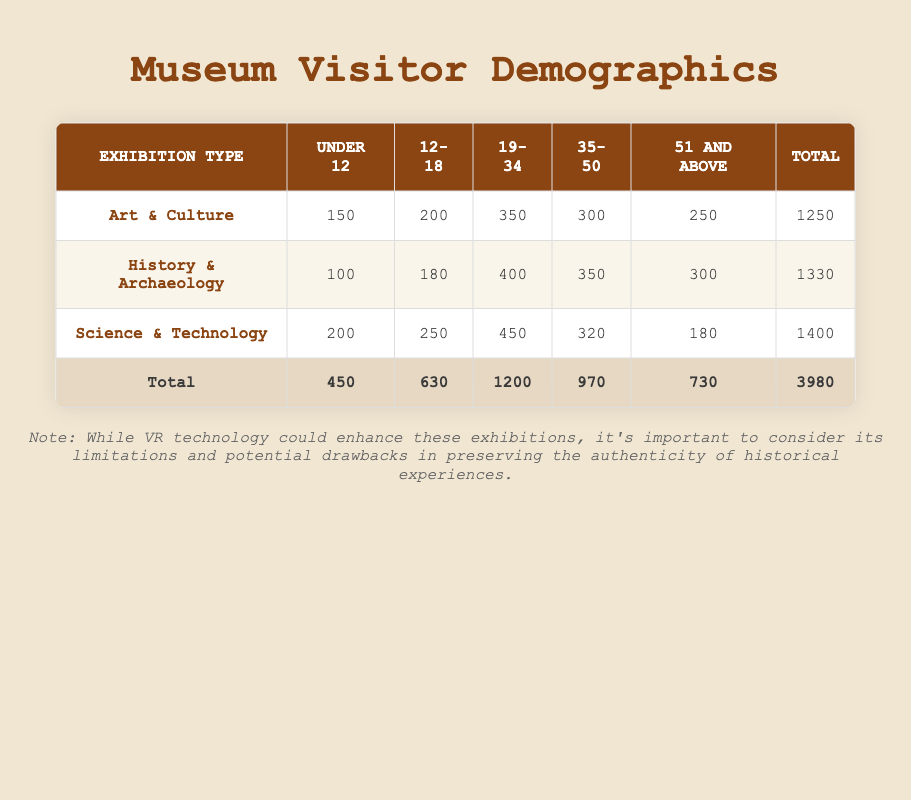What is the total number of visitors for the Art & Culture exhibition? The total number of visitors for the Art & Culture exhibition is found in the last column of the respective row. Looking at that row, the total number is 1250.
Answer: 1250 Which age group had the highest number of visitors in the Science & Technology exhibition? To determine which age group had the highest number of visitors for Science & Technology, we look at each age group under that exhibition type: Under 12 (200), 12-18 (250), 19-34 (450), 35-50 (320), and 51 and above (180). The highest number is 450, which corresponds to the age group 19-34.
Answer: 19-34 How many visitors aged 51 and above attended the History & Archaeology exhibition? The number of visitors aged 51 and above for the History & Archaeology exhibition is found directly in that row, which shows 300 visitors.
Answer: 300 What is the average number of visitors across all age groups for the Science & Technology exhibition? To find the average, first, we sum the number of visitors for all age groups in the Science & Technology exhibition: 200 + 250 + 450 + 320 + 180 = 1400. Then, divide by the number of age groups, which is 5. So, 1400/5 = 280.
Answer: 280 Is it true that the total number of visitors for History & Archaeology is greater than that for Art & Culture? We compare the total number of visitors for both exhibitions: History & Archaeology has 1330, while Art & Culture has 1250. Since 1330 is greater than 1250, the statement is true.
Answer: True What is the difference in the number of visitors between the 19-34 age group in Science & Technology and History & Archaeology? For Science & Technology, the 19-34 age group has 450 visitors, and for History & Archaeology, this group has 400 visitors. The difference is 450 - 400 = 50.
Answer: 50 Which exhibition type had the least number of visitors in the Under 12 age group? We compare the Under 12 visitor counts for each exhibition: Art & Culture (150), History & Archaeology (100), and Science & Technology (200). The least is 100 from the History & Archaeology exhibition.
Answer: History & Archaeology How many visitors attended exhibitions for the age group 12-18 across all exhibition types combined? We look at the 12-18 visitor numbers for all exhibition types: Art & Culture (200), History & Archaeology (180), and Science & Technology (250). Summing these gives 200 + 180 + 250 = 630.
Answer: 630 What percentage of the total visitors were from the age group 35-50? The total number of visitors across all age groups is 3980. The number of visitors from the 35-50 age group across all exhibitions is 970. To find the percentage: (970/3980) * 100 = 24.36%.
Answer: 24.36% 